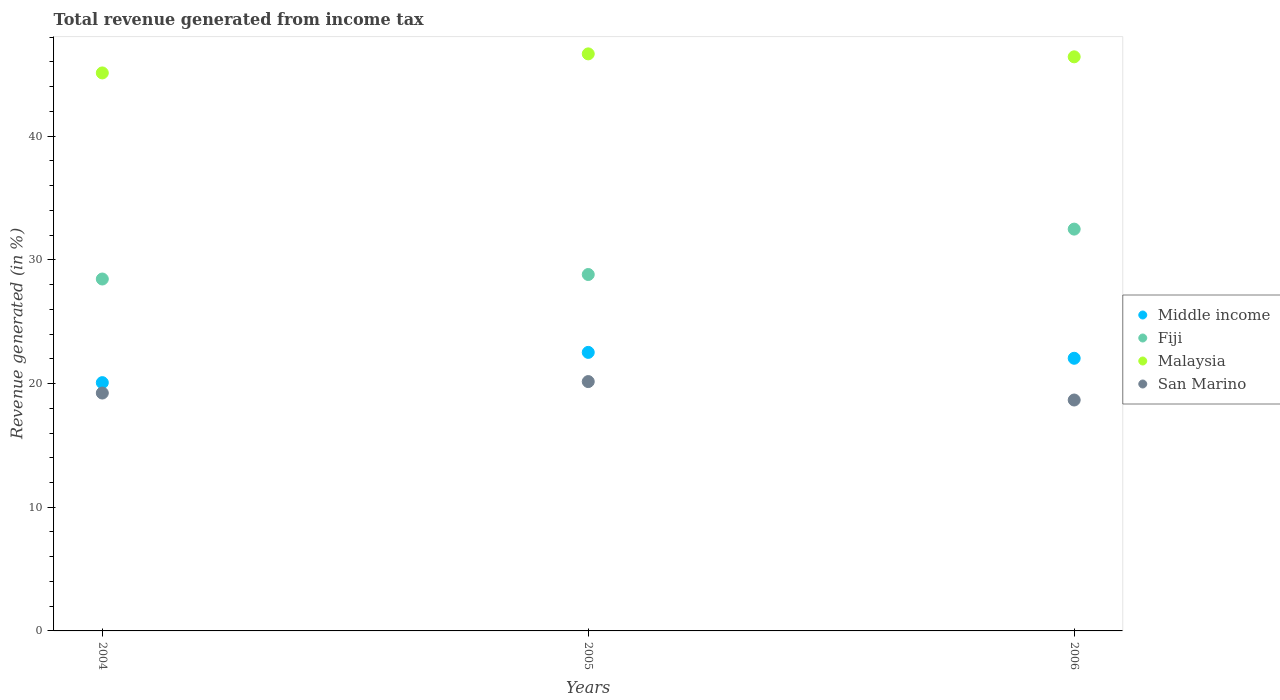How many different coloured dotlines are there?
Your response must be concise. 4. What is the total revenue generated in Fiji in 2005?
Keep it short and to the point. 28.82. Across all years, what is the maximum total revenue generated in Fiji?
Make the answer very short. 32.49. Across all years, what is the minimum total revenue generated in San Marino?
Keep it short and to the point. 18.67. In which year was the total revenue generated in Fiji minimum?
Offer a terse response. 2004. What is the total total revenue generated in Malaysia in the graph?
Your answer should be very brief. 138.19. What is the difference between the total revenue generated in San Marino in 2004 and that in 2005?
Your response must be concise. -0.93. What is the difference between the total revenue generated in San Marino in 2006 and the total revenue generated in Fiji in 2005?
Offer a very short reply. -10.15. What is the average total revenue generated in Malaysia per year?
Your answer should be compact. 46.06. In the year 2006, what is the difference between the total revenue generated in Fiji and total revenue generated in Malaysia?
Your answer should be compact. -13.93. In how many years, is the total revenue generated in Malaysia greater than 42 %?
Ensure brevity in your answer.  3. What is the ratio of the total revenue generated in Middle income in 2005 to that in 2006?
Offer a very short reply. 1.02. What is the difference between the highest and the second highest total revenue generated in Malaysia?
Offer a very short reply. 0.24. What is the difference between the highest and the lowest total revenue generated in Fiji?
Provide a short and direct response. 4.03. Is the sum of the total revenue generated in Middle income in 2004 and 2005 greater than the maximum total revenue generated in Fiji across all years?
Provide a short and direct response. Yes. Is it the case that in every year, the sum of the total revenue generated in Malaysia and total revenue generated in Middle income  is greater than the total revenue generated in Fiji?
Your answer should be very brief. Yes. Is the total revenue generated in Middle income strictly greater than the total revenue generated in Fiji over the years?
Give a very brief answer. No. How many years are there in the graph?
Your answer should be compact. 3. What is the difference between two consecutive major ticks on the Y-axis?
Provide a short and direct response. 10. Are the values on the major ticks of Y-axis written in scientific E-notation?
Offer a terse response. No. Does the graph contain grids?
Your response must be concise. No. How many legend labels are there?
Provide a short and direct response. 4. What is the title of the graph?
Your answer should be compact. Total revenue generated from income tax. Does "Rwanda" appear as one of the legend labels in the graph?
Your answer should be very brief. No. What is the label or title of the Y-axis?
Make the answer very short. Revenue generated (in %). What is the Revenue generated (in %) in Middle income in 2004?
Offer a terse response. 20.07. What is the Revenue generated (in %) in Fiji in 2004?
Make the answer very short. 28.45. What is the Revenue generated (in %) of Malaysia in 2004?
Offer a very short reply. 45.12. What is the Revenue generated (in %) in San Marino in 2004?
Your answer should be very brief. 19.23. What is the Revenue generated (in %) of Middle income in 2005?
Your answer should be very brief. 22.52. What is the Revenue generated (in %) of Fiji in 2005?
Keep it short and to the point. 28.82. What is the Revenue generated (in %) in Malaysia in 2005?
Make the answer very short. 46.66. What is the Revenue generated (in %) of San Marino in 2005?
Keep it short and to the point. 20.16. What is the Revenue generated (in %) in Middle income in 2006?
Your answer should be compact. 22.04. What is the Revenue generated (in %) of Fiji in 2006?
Your response must be concise. 32.49. What is the Revenue generated (in %) of Malaysia in 2006?
Ensure brevity in your answer.  46.42. What is the Revenue generated (in %) in San Marino in 2006?
Your response must be concise. 18.67. Across all years, what is the maximum Revenue generated (in %) of Middle income?
Provide a succinct answer. 22.52. Across all years, what is the maximum Revenue generated (in %) of Fiji?
Your answer should be compact. 32.49. Across all years, what is the maximum Revenue generated (in %) in Malaysia?
Your response must be concise. 46.66. Across all years, what is the maximum Revenue generated (in %) of San Marino?
Make the answer very short. 20.16. Across all years, what is the minimum Revenue generated (in %) of Middle income?
Give a very brief answer. 20.07. Across all years, what is the minimum Revenue generated (in %) of Fiji?
Your answer should be very brief. 28.45. Across all years, what is the minimum Revenue generated (in %) in Malaysia?
Make the answer very short. 45.12. Across all years, what is the minimum Revenue generated (in %) of San Marino?
Provide a short and direct response. 18.67. What is the total Revenue generated (in %) in Middle income in the graph?
Offer a terse response. 64.64. What is the total Revenue generated (in %) in Fiji in the graph?
Keep it short and to the point. 89.76. What is the total Revenue generated (in %) of Malaysia in the graph?
Keep it short and to the point. 138.19. What is the total Revenue generated (in %) in San Marino in the graph?
Make the answer very short. 58.06. What is the difference between the Revenue generated (in %) of Middle income in 2004 and that in 2005?
Ensure brevity in your answer.  -2.45. What is the difference between the Revenue generated (in %) of Fiji in 2004 and that in 2005?
Provide a short and direct response. -0.36. What is the difference between the Revenue generated (in %) in Malaysia in 2004 and that in 2005?
Ensure brevity in your answer.  -1.54. What is the difference between the Revenue generated (in %) in San Marino in 2004 and that in 2005?
Ensure brevity in your answer.  -0.93. What is the difference between the Revenue generated (in %) in Middle income in 2004 and that in 2006?
Your answer should be very brief. -1.97. What is the difference between the Revenue generated (in %) in Fiji in 2004 and that in 2006?
Ensure brevity in your answer.  -4.03. What is the difference between the Revenue generated (in %) of Malaysia in 2004 and that in 2006?
Your answer should be compact. -1.3. What is the difference between the Revenue generated (in %) in San Marino in 2004 and that in 2006?
Your response must be concise. 0.56. What is the difference between the Revenue generated (in %) in Middle income in 2005 and that in 2006?
Offer a very short reply. 0.48. What is the difference between the Revenue generated (in %) in Fiji in 2005 and that in 2006?
Your answer should be very brief. -3.67. What is the difference between the Revenue generated (in %) in Malaysia in 2005 and that in 2006?
Give a very brief answer. 0.24. What is the difference between the Revenue generated (in %) in San Marino in 2005 and that in 2006?
Keep it short and to the point. 1.49. What is the difference between the Revenue generated (in %) in Middle income in 2004 and the Revenue generated (in %) in Fiji in 2005?
Keep it short and to the point. -8.74. What is the difference between the Revenue generated (in %) in Middle income in 2004 and the Revenue generated (in %) in Malaysia in 2005?
Your answer should be compact. -26.58. What is the difference between the Revenue generated (in %) in Middle income in 2004 and the Revenue generated (in %) in San Marino in 2005?
Offer a terse response. -0.09. What is the difference between the Revenue generated (in %) of Fiji in 2004 and the Revenue generated (in %) of Malaysia in 2005?
Make the answer very short. -18.2. What is the difference between the Revenue generated (in %) in Fiji in 2004 and the Revenue generated (in %) in San Marino in 2005?
Ensure brevity in your answer.  8.29. What is the difference between the Revenue generated (in %) in Malaysia in 2004 and the Revenue generated (in %) in San Marino in 2005?
Your answer should be very brief. 24.96. What is the difference between the Revenue generated (in %) in Middle income in 2004 and the Revenue generated (in %) in Fiji in 2006?
Provide a short and direct response. -12.41. What is the difference between the Revenue generated (in %) in Middle income in 2004 and the Revenue generated (in %) in Malaysia in 2006?
Offer a very short reply. -26.34. What is the difference between the Revenue generated (in %) in Middle income in 2004 and the Revenue generated (in %) in San Marino in 2006?
Give a very brief answer. 1.4. What is the difference between the Revenue generated (in %) of Fiji in 2004 and the Revenue generated (in %) of Malaysia in 2006?
Your answer should be very brief. -17.96. What is the difference between the Revenue generated (in %) in Fiji in 2004 and the Revenue generated (in %) in San Marino in 2006?
Your answer should be compact. 9.78. What is the difference between the Revenue generated (in %) in Malaysia in 2004 and the Revenue generated (in %) in San Marino in 2006?
Provide a succinct answer. 26.45. What is the difference between the Revenue generated (in %) of Middle income in 2005 and the Revenue generated (in %) of Fiji in 2006?
Offer a very short reply. -9.97. What is the difference between the Revenue generated (in %) of Middle income in 2005 and the Revenue generated (in %) of Malaysia in 2006?
Ensure brevity in your answer.  -23.9. What is the difference between the Revenue generated (in %) in Middle income in 2005 and the Revenue generated (in %) in San Marino in 2006?
Provide a short and direct response. 3.85. What is the difference between the Revenue generated (in %) in Fiji in 2005 and the Revenue generated (in %) in Malaysia in 2006?
Give a very brief answer. -17.6. What is the difference between the Revenue generated (in %) in Fiji in 2005 and the Revenue generated (in %) in San Marino in 2006?
Offer a terse response. 10.15. What is the difference between the Revenue generated (in %) in Malaysia in 2005 and the Revenue generated (in %) in San Marino in 2006?
Give a very brief answer. 27.99. What is the average Revenue generated (in %) in Middle income per year?
Your response must be concise. 21.55. What is the average Revenue generated (in %) of Fiji per year?
Offer a very short reply. 29.92. What is the average Revenue generated (in %) in Malaysia per year?
Ensure brevity in your answer.  46.06. What is the average Revenue generated (in %) in San Marino per year?
Provide a succinct answer. 19.35. In the year 2004, what is the difference between the Revenue generated (in %) of Middle income and Revenue generated (in %) of Fiji?
Make the answer very short. -8.38. In the year 2004, what is the difference between the Revenue generated (in %) of Middle income and Revenue generated (in %) of Malaysia?
Keep it short and to the point. -25.04. In the year 2004, what is the difference between the Revenue generated (in %) in Middle income and Revenue generated (in %) in San Marino?
Your answer should be very brief. 0.84. In the year 2004, what is the difference between the Revenue generated (in %) of Fiji and Revenue generated (in %) of Malaysia?
Your response must be concise. -16.66. In the year 2004, what is the difference between the Revenue generated (in %) in Fiji and Revenue generated (in %) in San Marino?
Your answer should be very brief. 9.22. In the year 2004, what is the difference between the Revenue generated (in %) of Malaysia and Revenue generated (in %) of San Marino?
Your answer should be compact. 25.88. In the year 2005, what is the difference between the Revenue generated (in %) of Middle income and Revenue generated (in %) of Fiji?
Provide a succinct answer. -6.3. In the year 2005, what is the difference between the Revenue generated (in %) of Middle income and Revenue generated (in %) of Malaysia?
Provide a short and direct response. -24.14. In the year 2005, what is the difference between the Revenue generated (in %) in Middle income and Revenue generated (in %) in San Marino?
Your response must be concise. 2.36. In the year 2005, what is the difference between the Revenue generated (in %) of Fiji and Revenue generated (in %) of Malaysia?
Your response must be concise. -17.84. In the year 2005, what is the difference between the Revenue generated (in %) of Fiji and Revenue generated (in %) of San Marino?
Give a very brief answer. 8.66. In the year 2005, what is the difference between the Revenue generated (in %) in Malaysia and Revenue generated (in %) in San Marino?
Your answer should be compact. 26.5. In the year 2006, what is the difference between the Revenue generated (in %) of Middle income and Revenue generated (in %) of Fiji?
Your answer should be compact. -10.44. In the year 2006, what is the difference between the Revenue generated (in %) of Middle income and Revenue generated (in %) of Malaysia?
Offer a very short reply. -24.37. In the year 2006, what is the difference between the Revenue generated (in %) in Middle income and Revenue generated (in %) in San Marino?
Make the answer very short. 3.38. In the year 2006, what is the difference between the Revenue generated (in %) of Fiji and Revenue generated (in %) of Malaysia?
Your response must be concise. -13.93. In the year 2006, what is the difference between the Revenue generated (in %) in Fiji and Revenue generated (in %) in San Marino?
Your answer should be very brief. 13.82. In the year 2006, what is the difference between the Revenue generated (in %) in Malaysia and Revenue generated (in %) in San Marino?
Provide a short and direct response. 27.75. What is the ratio of the Revenue generated (in %) in Middle income in 2004 to that in 2005?
Your answer should be very brief. 0.89. What is the ratio of the Revenue generated (in %) of Fiji in 2004 to that in 2005?
Keep it short and to the point. 0.99. What is the ratio of the Revenue generated (in %) of San Marino in 2004 to that in 2005?
Your answer should be compact. 0.95. What is the ratio of the Revenue generated (in %) in Middle income in 2004 to that in 2006?
Ensure brevity in your answer.  0.91. What is the ratio of the Revenue generated (in %) in Fiji in 2004 to that in 2006?
Offer a very short reply. 0.88. What is the ratio of the Revenue generated (in %) of San Marino in 2004 to that in 2006?
Make the answer very short. 1.03. What is the ratio of the Revenue generated (in %) in Middle income in 2005 to that in 2006?
Provide a short and direct response. 1.02. What is the ratio of the Revenue generated (in %) of Fiji in 2005 to that in 2006?
Your answer should be compact. 0.89. What is the ratio of the Revenue generated (in %) in San Marino in 2005 to that in 2006?
Your answer should be compact. 1.08. What is the difference between the highest and the second highest Revenue generated (in %) in Middle income?
Give a very brief answer. 0.48. What is the difference between the highest and the second highest Revenue generated (in %) of Fiji?
Ensure brevity in your answer.  3.67. What is the difference between the highest and the second highest Revenue generated (in %) of Malaysia?
Make the answer very short. 0.24. What is the difference between the highest and the second highest Revenue generated (in %) in San Marino?
Make the answer very short. 0.93. What is the difference between the highest and the lowest Revenue generated (in %) in Middle income?
Your answer should be compact. 2.45. What is the difference between the highest and the lowest Revenue generated (in %) in Fiji?
Provide a short and direct response. 4.03. What is the difference between the highest and the lowest Revenue generated (in %) of Malaysia?
Give a very brief answer. 1.54. What is the difference between the highest and the lowest Revenue generated (in %) of San Marino?
Offer a terse response. 1.49. 